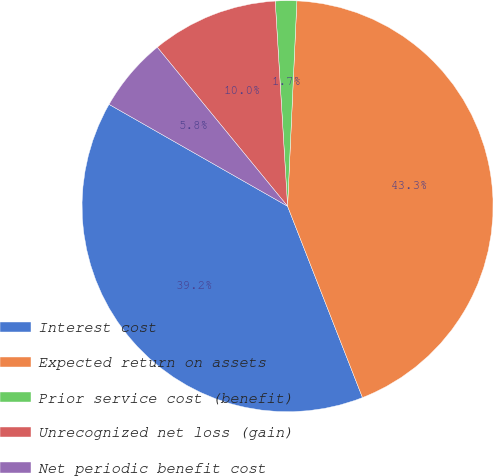<chart> <loc_0><loc_0><loc_500><loc_500><pie_chart><fcel>Interest cost<fcel>Expected return on assets<fcel>Prior service cost (benefit)<fcel>Unrecognized net loss (gain)<fcel>Net periodic benefit cost<nl><fcel>39.19%<fcel>43.34%<fcel>1.68%<fcel>9.97%<fcel>5.82%<nl></chart> 